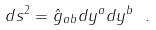<formula> <loc_0><loc_0><loc_500><loc_500>d s ^ { 2 } = \hat { g } _ { a b } d y ^ { a } d y ^ { b } \ .</formula> 